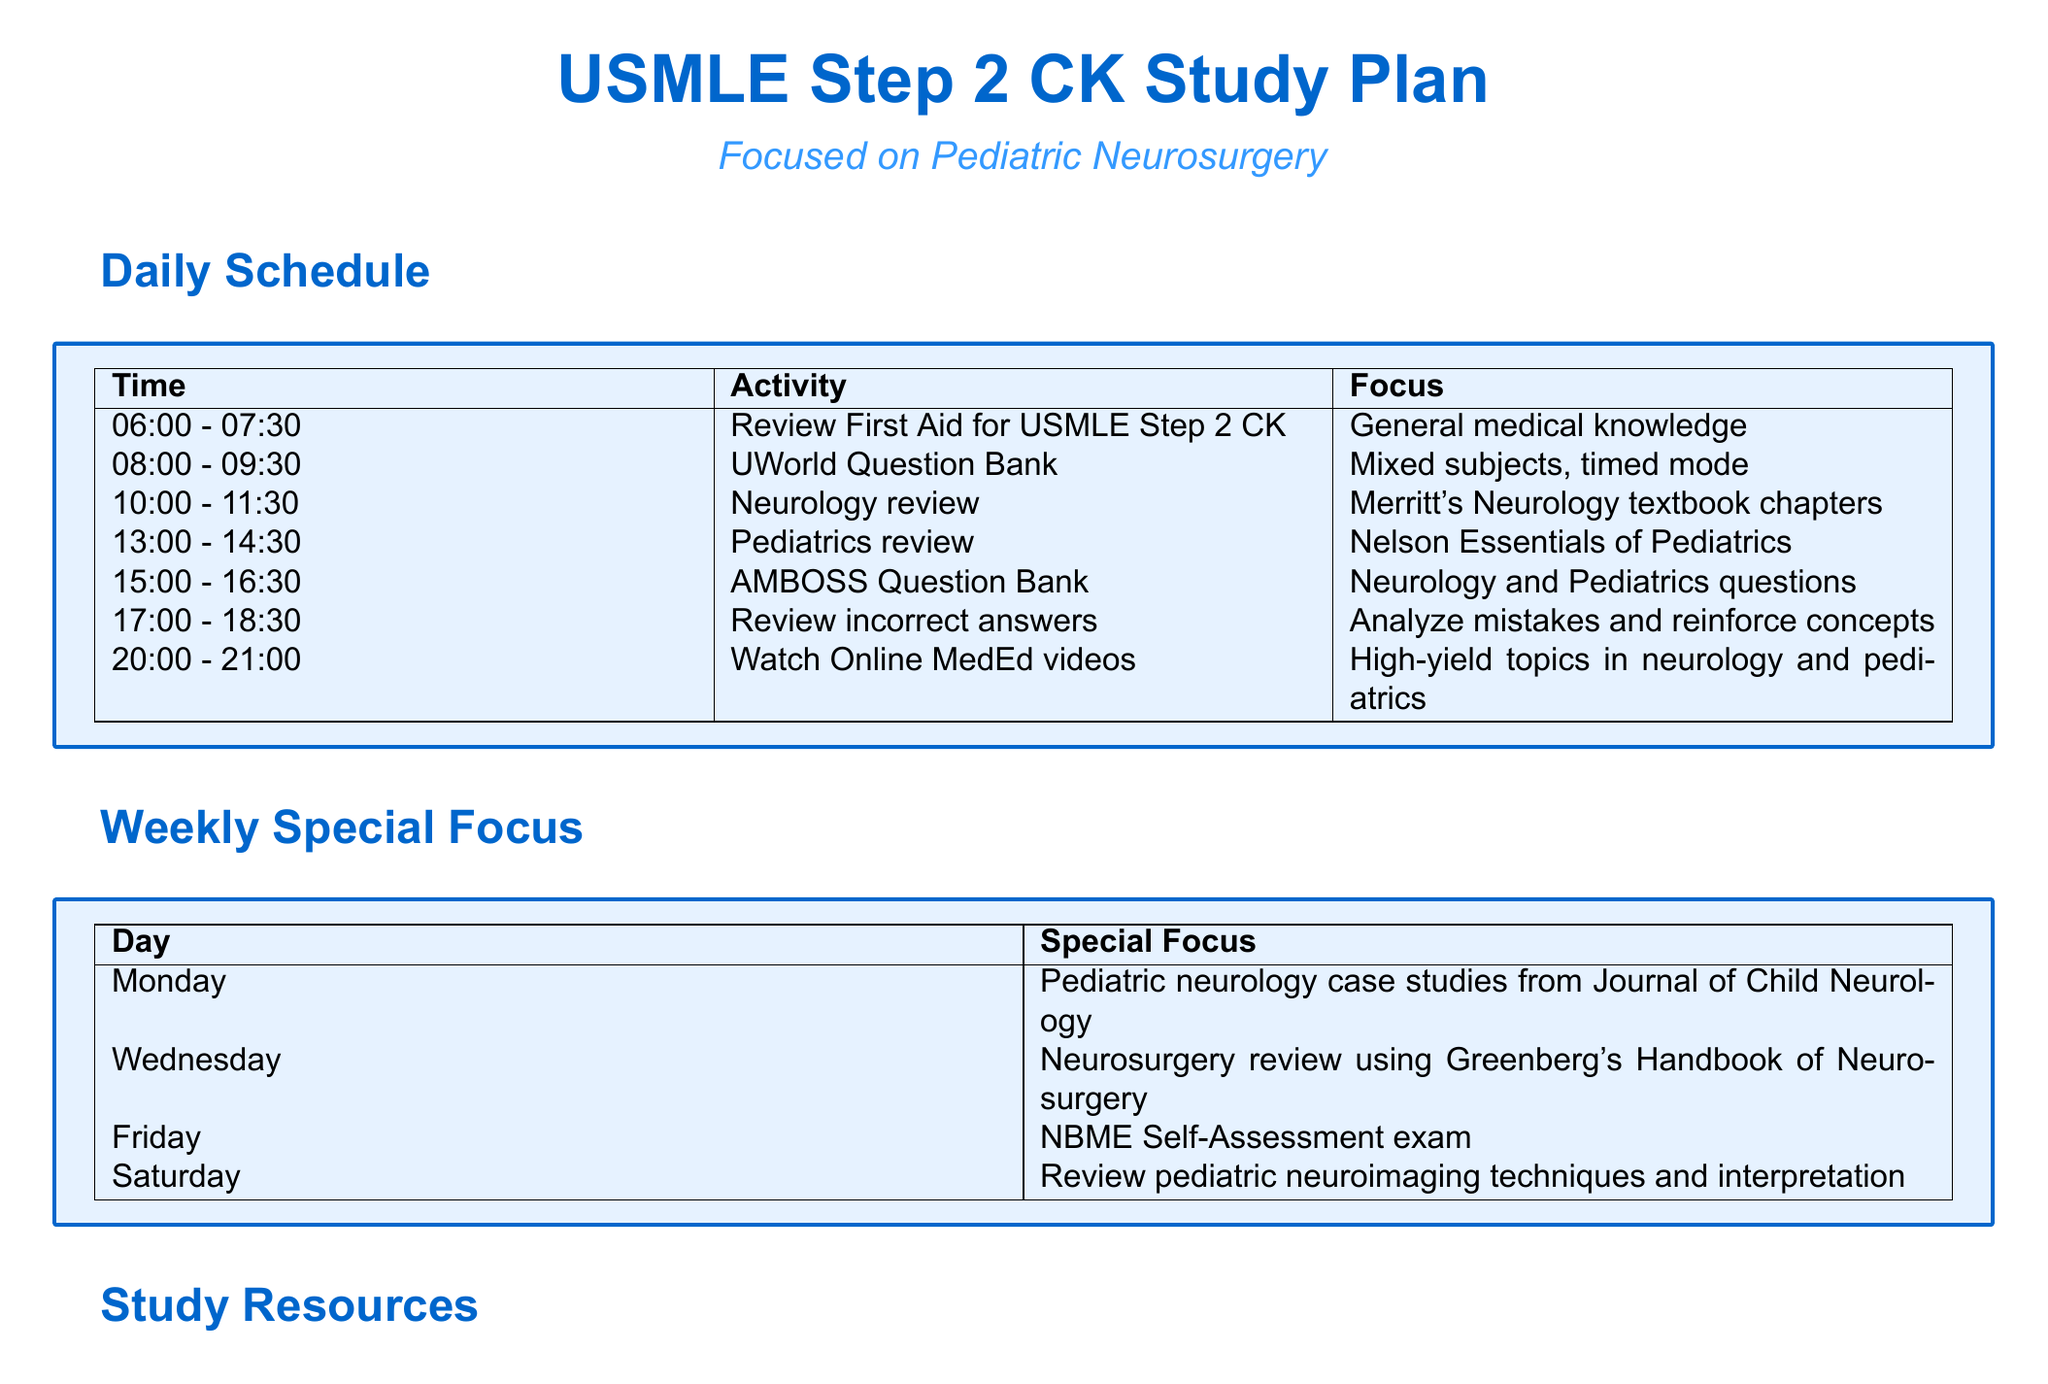What time is the Neurology review scheduled? The Neurology review is scheduled from 10:00 to 11:30.
Answer: 10:00 - 11:30 What resource is used for pediatrics review? The resource used for pediatrics review is the Nelson Essentials of Pediatrics.
Answer: Nelson Essentials of Pediatrics On which day is the NBME Self-Assessment exam scheduled? The NBME Self-Assessment exam is scheduled on Friday.
Answer: Friday How often are pediatric neurosurgery landmark papers reviewed? Landmark papers in pediatric neurosurgery are reviewed daily, for 30 minutes.
Answer: Daily, 30 minutes What is the primary focus of the first activity in the daily schedule? The primary focus of the first activity is general medical knowledge.
Answer: General medical knowledge 